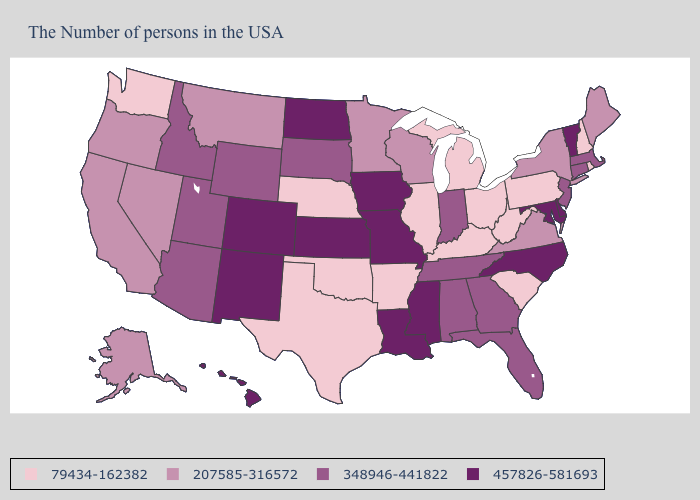Does the map have missing data?
Give a very brief answer. No. What is the highest value in the South ?
Give a very brief answer. 457826-581693. What is the value of North Carolina?
Short answer required. 457826-581693. Name the states that have a value in the range 207585-316572?
Give a very brief answer. Maine, New York, Virginia, Wisconsin, Minnesota, Montana, Nevada, California, Oregon, Alaska. Name the states that have a value in the range 348946-441822?
Answer briefly. Massachusetts, Connecticut, New Jersey, Florida, Georgia, Indiana, Alabama, Tennessee, South Dakota, Wyoming, Utah, Arizona, Idaho. Does Indiana have a lower value than Kansas?
Keep it brief. Yes. What is the value of North Carolina?
Answer briefly. 457826-581693. Name the states that have a value in the range 207585-316572?
Concise answer only. Maine, New York, Virginia, Wisconsin, Minnesota, Montana, Nevada, California, Oregon, Alaska. What is the value of West Virginia?
Give a very brief answer. 79434-162382. Does Nebraska have the lowest value in the USA?
Write a very short answer. Yes. Name the states that have a value in the range 348946-441822?
Give a very brief answer. Massachusetts, Connecticut, New Jersey, Florida, Georgia, Indiana, Alabama, Tennessee, South Dakota, Wyoming, Utah, Arizona, Idaho. What is the highest value in states that border Virginia?
Concise answer only. 457826-581693. What is the value of New Hampshire?
Quick response, please. 79434-162382. Which states hav the highest value in the Northeast?
Concise answer only. Vermont. 